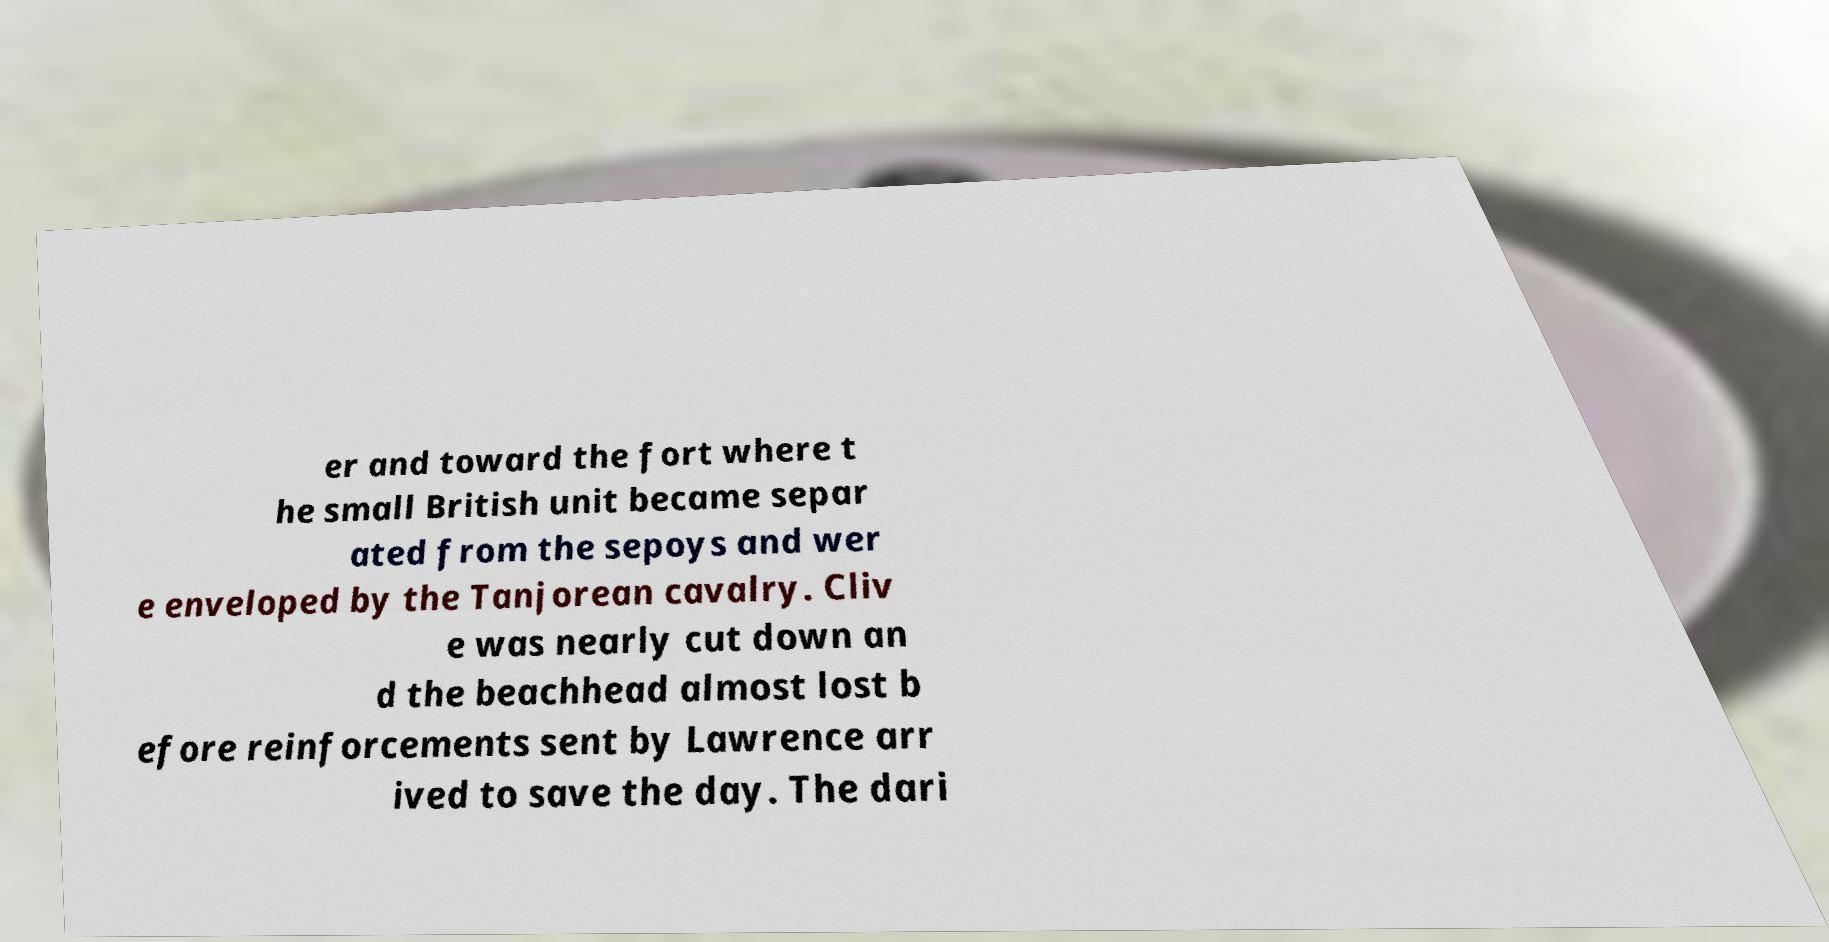What messages or text are displayed in this image? I need them in a readable, typed format. er and toward the fort where t he small British unit became separ ated from the sepoys and wer e enveloped by the Tanjorean cavalry. Cliv e was nearly cut down an d the beachhead almost lost b efore reinforcements sent by Lawrence arr ived to save the day. The dari 